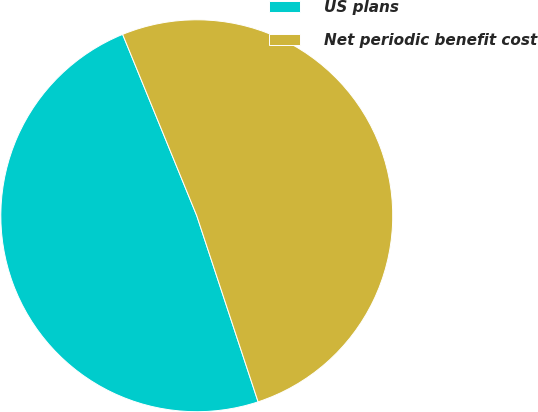Convert chart. <chart><loc_0><loc_0><loc_500><loc_500><pie_chart><fcel>US plans<fcel>Net periodic benefit cost<nl><fcel>48.89%<fcel>51.11%<nl></chart> 